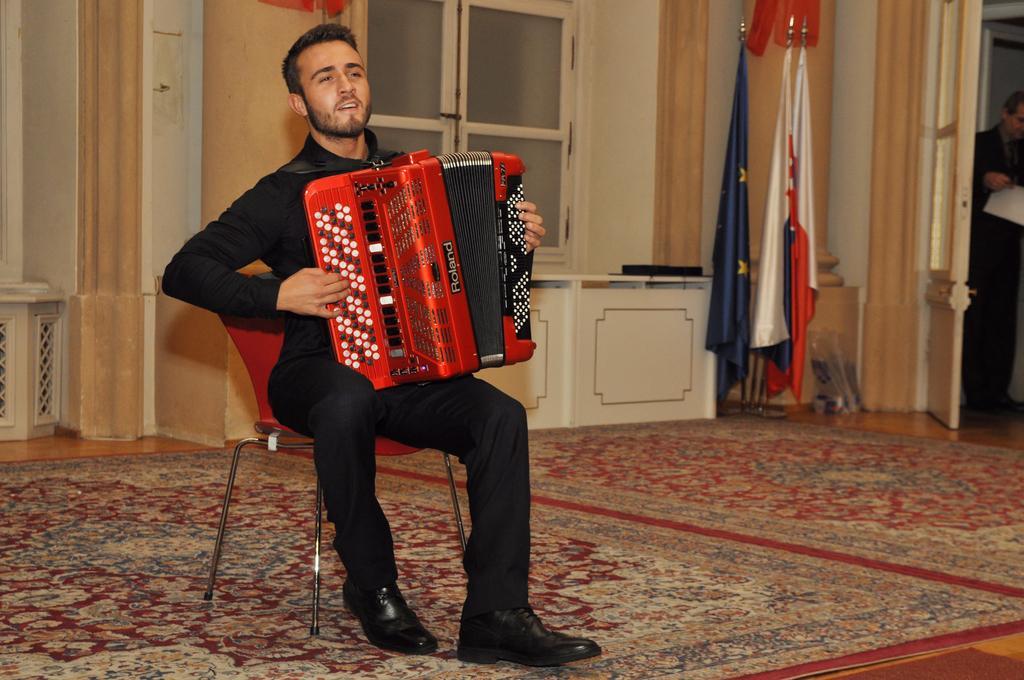Describe this image in one or two sentences. In this image, there are a few people. Among them, we can see a person playing a musical instrument is sitting on a chair. We can see the ground with some objects. We can see the windows and a door. We can see a pillar. We can see some flags. We can see the wall. 